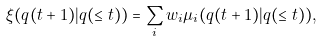Convert formula to latex. <formula><loc_0><loc_0><loc_500><loc_500>\xi ( q ( t + 1 ) | q ( \leq t ) ) = \sum _ { i } w _ { i } \mu _ { i } ( q ( t + 1 ) | q ( \leq t ) ) ,</formula> 